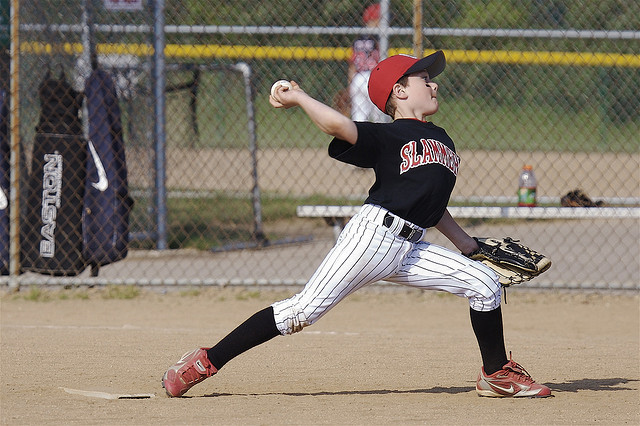Please transcribe the text in this image. SLAMM BASTON 